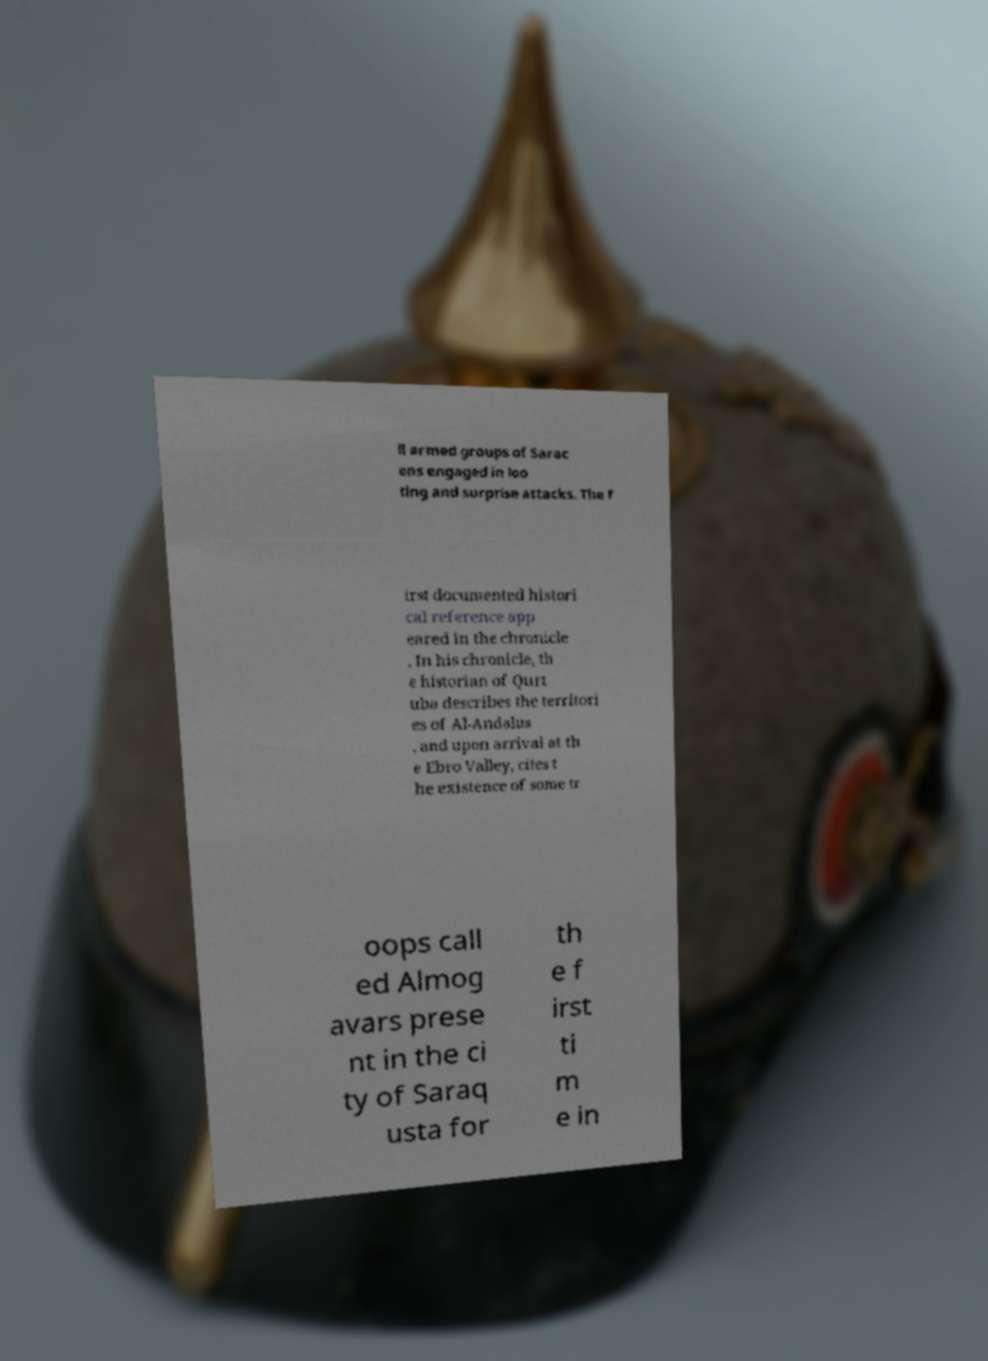Could you extract and type out the text from this image? ll armed groups of Sarac ens engaged in loo ting and surprise attacks. The f irst documented histori cal reference app eared in the chronicle . In his chronicle, th e historian of Qurt uba describes the territori es of Al-Andalus , and upon arrival at th e Ebro Valley, cites t he existence of some tr oops call ed Almog avars prese nt in the ci ty of Saraq usta for th e f irst ti m e in 